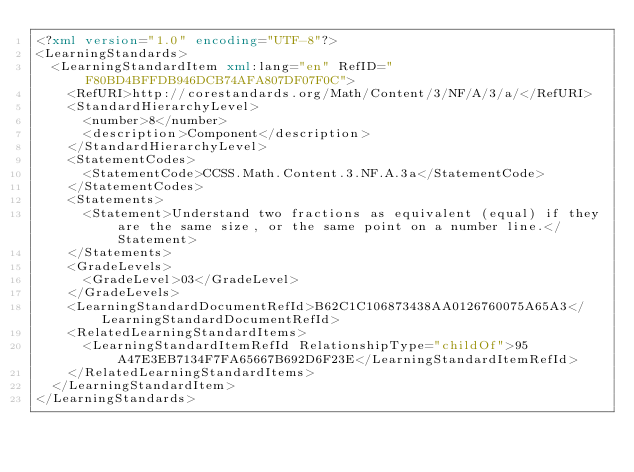Convert code to text. <code><loc_0><loc_0><loc_500><loc_500><_XML_><?xml version="1.0" encoding="UTF-8"?>
<LearningStandards>
  <LearningStandardItem xml:lang="en" RefID="F80BD4BFFDB946DCB74AFA807DF07F0C">
    <RefURI>http://corestandards.org/Math/Content/3/NF/A/3/a/</RefURI>
    <StandardHierarchyLevel>
      <number>8</number>
      <description>Component</description>
    </StandardHierarchyLevel>
    <StatementCodes>
      <StatementCode>CCSS.Math.Content.3.NF.A.3a</StatementCode>
    </StatementCodes>
    <Statements>
      <Statement>Understand two fractions as equivalent (equal) if they are the same size, or the same point on a number line.</Statement>
    </Statements>
    <GradeLevels>
      <GradeLevel>03</GradeLevel>
    </GradeLevels>
    <LearningStandardDocumentRefId>B62C1C106873438AA0126760075A65A3</LearningStandardDocumentRefId>
    <RelatedLearningStandardItems>
      <LearningStandardItemRefId RelationshipType="childOf">95A47E3EB7134F7FA65667B692D6F23E</LearningStandardItemRefId>
    </RelatedLearningStandardItems>
  </LearningStandardItem>
</LearningStandards>
</code> 